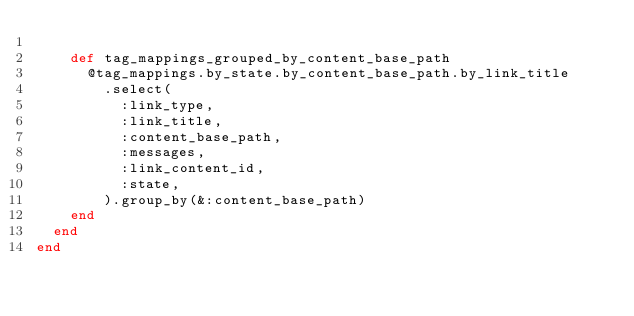<code> <loc_0><loc_0><loc_500><loc_500><_Ruby_>
    def tag_mappings_grouped_by_content_base_path
      @tag_mappings.by_state.by_content_base_path.by_link_title
        .select(
          :link_type,
          :link_title,
          :content_base_path,
          :messages,
          :link_content_id,
          :state,
        ).group_by(&:content_base_path)
    end
  end
end
</code> 